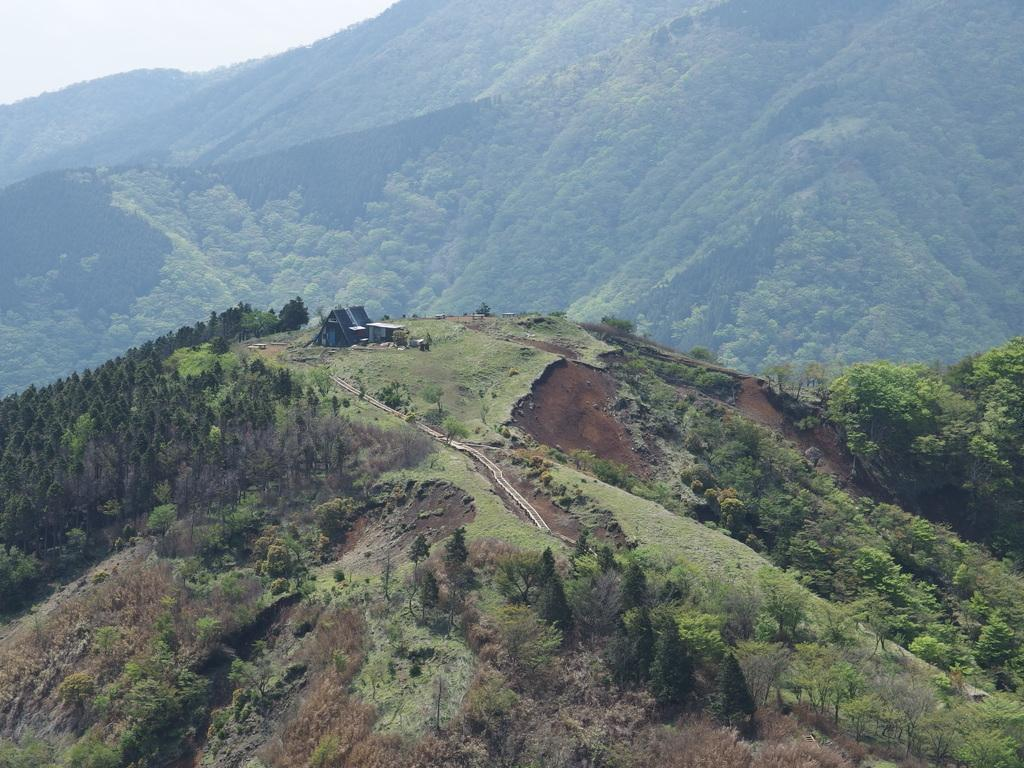What type of natural formation can be seen in the image? There are mountains in the image. What type of vegetation is present in the image? Trees, plants, and grass are visible in the image. What part of the sky is visible in the image? The sky is visible in the image. Can you describe the structure on one of the mountains? There is a small house on one of the mountains. What man-made feature can be seen in the image? There is a road in the image. What type of teeth does the owner of the small house have? There is no information about the owner of the small house or their teeth in the image. 